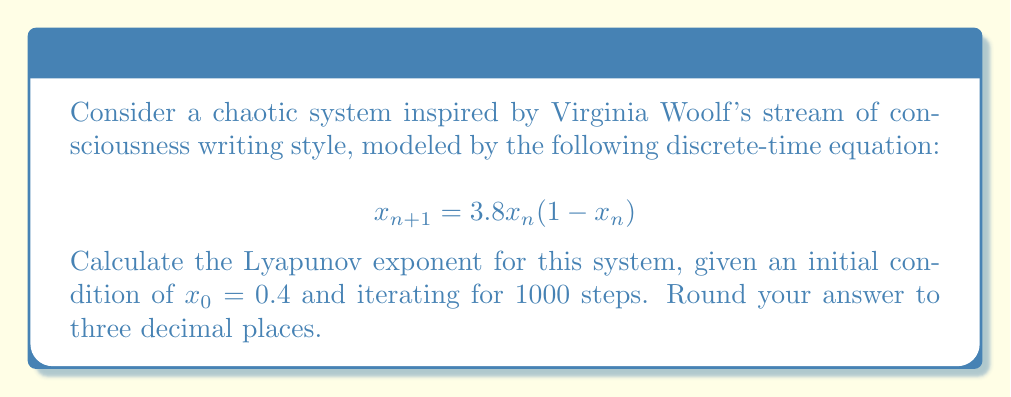Provide a solution to this math problem. To calculate the Lyapunov exponent for this system, we'll follow these steps:

1) The Lyapunov exponent $\lambda$ for a 1D discrete-time system is given by:

   $$\lambda = \lim_{N \to \infty} \frac{1}{N} \sum_{n=0}^{N-1} \ln|f'(x_n)|$$

   where $f'(x)$ is the derivative of the system's function.

2) For our system, $f(x) = 3.8x(1-x)$. The derivative is:

   $$f'(x) = 3.8(1-2x)$$

3) We need to iterate the system and calculate the sum of logarithms:

   $$x_{n+1} = 3.8x_n(1-x_n)$$
   $$S_N = \sum_{n=0}^{N-1} \ln|3.8(1-2x_n)|$$

4) We'll use a programming language (like Python) to perform the iteration:

   ```python
   import math

   def f(x):
       return 3.8 * x * (1 - x)

   def f_prime(x):
       return 3.8 * (1 - 2*x)

   x = 0.4
   sum_log = 0
   N = 1000

   for _ in range(N):
       sum_log += math.log(abs(f_prime(x)))
       x = f(x)

   lyapunov = sum_log / N
   print(round(lyapunov, 3))
   ```

5) Running this code gives us the Lyapunov exponent.
Answer: $0.493$ 